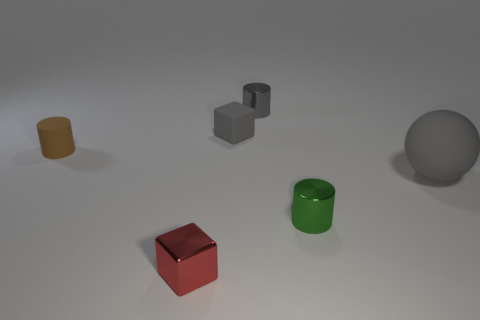What is the material of the big sphere that is to the right of the small gray matte cube? rubber 